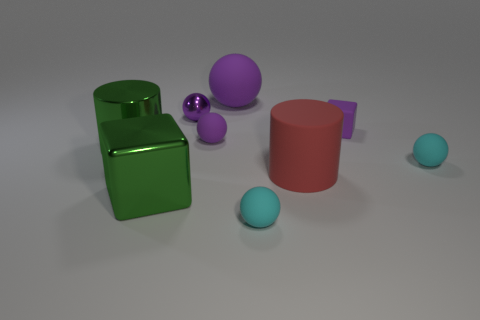Subtract all purple cubes. How many purple spheres are left? 3 Subtract all metal balls. How many balls are left? 4 Subtract all green balls. Subtract all green cylinders. How many balls are left? 5 Subtract all cubes. How many objects are left? 7 Add 9 tiny purple metallic spheres. How many tiny purple metallic spheres exist? 10 Subtract 0 yellow balls. How many objects are left? 9 Subtract all green cylinders. Subtract all large red cylinders. How many objects are left? 7 Add 6 purple shiny spheres. How many purple shiny spheres are left? 7 